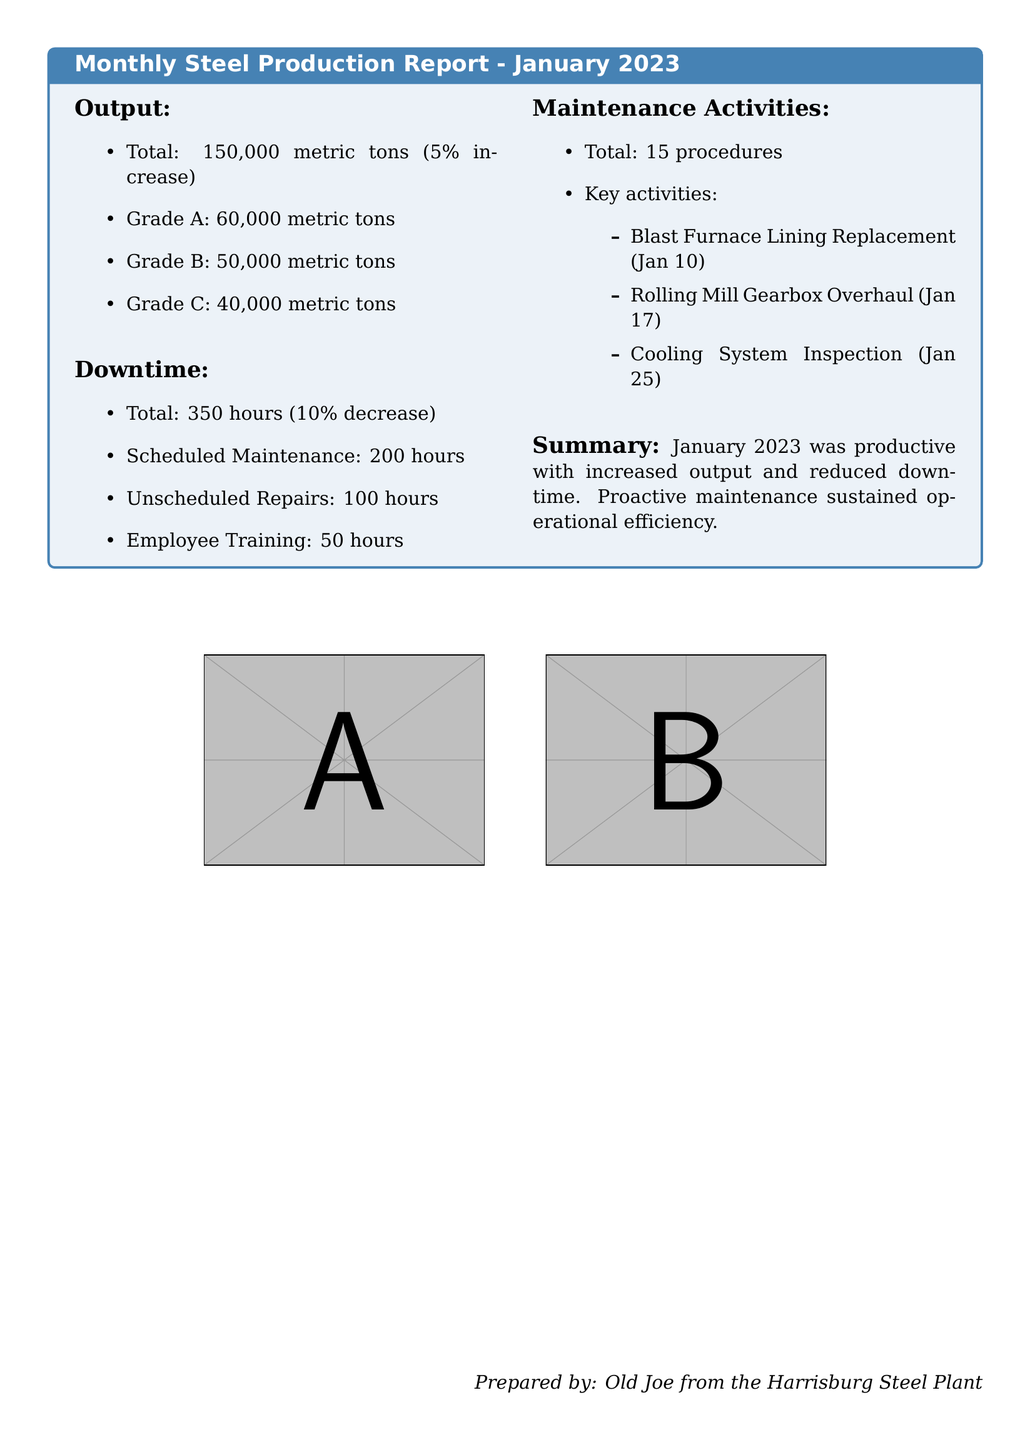what was the total steel output in January 2023? The total steel output is specified in the report as 150,000 metric tons.
Answer: 150,000 metric tons how much did downtime decrease in January 2023? The report states a 10% decrease in total downtime for that month.
Answer: 10% decrease what percentage of the total output was Grade A steel? The report indicates that Grade A steel was 60,000 metric tons out of 150,000 metric tons, which corresponds to 40%.
Answer: 40% how many unscheduled repair hours were recorded? According to the downtime section, there were 100 hours of unscheduled repairs.
Answer: 100 hours what key maintenance activity took place on January 17? The report lists the Rolling Mill Gearbox Overhaul as the key activity on this date.
Answer: Rolling Mill Gearbox Overhaul how many maintenance procedures were completed in January 2023? The report indicates a total of 15 maintenance procedures were performed.
Answer: 15 procedures what is the main takeaway from the summary? The summary highlights that January 2023 was productive with increased output and reduced downtime.
Answer: Increased output and reduced downtime what was the total scheduled maintenance time? The document specifies that scheduled maintenance took 200 hours in January 2023.
Answer: 200 hours 